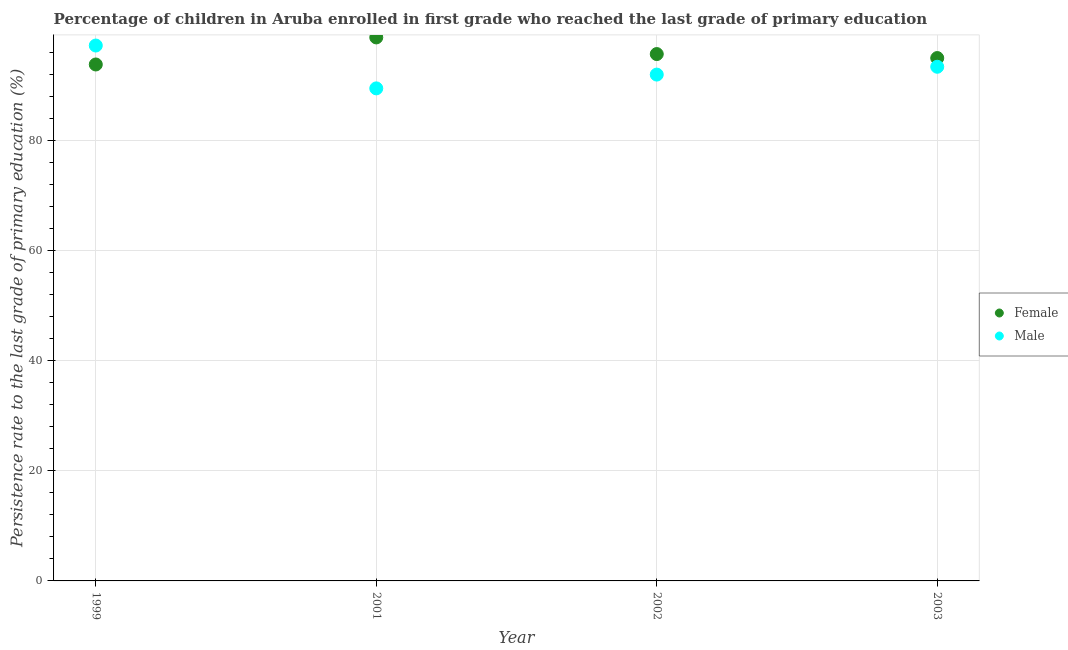How many different coloured dotlines are there?
Give a very brief answer. 2. What is the persistence rate of female students in 2001?
Ensure brevity in your answer.  98.8. Across all years, what is the maximum persistence rate of female students?
Your response must be concise. 98.8. Across all years, what is the minimum persistence rate of female students?
Make the answer very short. 93.88. In which year was the persistence rate of female students minimum?
Give a very brief answer. 1999. What is the total persistence rate of female students in the graph?
Your response must be concise. 383.49. What is the difference between the persistence rate of male students in 2002 and that in 2003?
Offer a terse response. -1.42. What is the difference between the persistence rate of female students in 2003 and the persistence rate of male students in 2002?
Offer a very short reply. 3.01. What is the average persistence rate of male students per year?
Your answer should be very brief. 93.09. In the year 1999, what is the difference between the persistence rate of male students and persistence rate of female students?
Your answer should be very brief. 3.44. What is the ratio of the persistence rate of male students in 2001 to that in 2003?
Ensure brevity in your answer.  0.96. Is the persistence rate of female students in 1999 less than that in 2001?
Offer a terse response. Yes. What is the difference between the highest and the second highest persistence rate of female students?
Make the answer very short. 3.02. What is the difference between the highest and the lowest persistence rate of male students?
Your answer should be very brief. 7.79. Is the sum of the persistence rate of female students in 1999 and 2002 greater than the maximum persistence rate of male students across all years?
Your response must be concise. Yes. Does the persistence rate of male students monotonically increase over the years?
Your answer should be very brief. No. How many years are there in the graph?
Give a very brief answer. 4. What is the difference between two consecutive major ticks on the Y-axis?
Offer a terse response. 20. Are the values on the major ticks of Y-axis written in scientific E-notation?
Provide a succinct answer. No. Does the graph contain any zero values?
Provide a short and direct response. No. Does the graph contain grids?
Provide a succinct answer. Yes. Where does the legend appear in the graph?
Keep it short and to the point. Center right. How many legend labels are there?
Keep it short and to the point. 2. How are the legend labels stacked?
Provide a short and direct response. Vertical. What is the title of the graph?
Your answer should be very brief. Percentage of children in Aruba enrolled in first grade who reached the last grade of primary education. Does "Food and tobacco" appear as one of the legend labels in the graph?
Make the answer very short. No. What is the label or title of the X-axis?
Offer a terse response. Year. What is the label or title of the Y-axis?
Give a very brief answer. Persistence rate to the last grade of primary education (%). What is the Persistence rate to the last grade of primary education (%) in Female in 1999?
Your response must be concise. 93.88. What is the Persistence rate to the last grade of primary education (%) of Male in 1999?
Provide a short and direct response. 97.32. What is the Persistence rate to the last grade of primary education (%) in Female in 2001?
Provide a short and direct response. 98.8. What is the Persistence rate to the last grade of primary education (%) of Male in 2001?
Provide a succinct answer. 89.53. What is the Persistence rate to the last grade of primary education (%) in Female in 2002?
Ensure brevity in your answer.  95.77. What is the Persistence rate to the last grade of primary education (%) in Male in 2002?
Offer a terse response. 92.04. What is the Persistence rate to the last grade of primary education (%) of Female in 2003?
Provide a short and direct response. 95.05. What is the Persistence rate to the last grade of primary education (%) of Male in 2003?
Ensure brevity in your answer.  93.46. Across all years, what is the maximum Persistence rate to the last grade of primary education (%) of Female?
Your answer should be very brief. 98.8. Across all years, what is the maximum Persistence rate to the last grade of primary education (%) of Male?
Your answer should be compact. 97.32. Across all years, what is the minimum Persistence rate to the last grade of primary education (%) of Female?
Offer a very short reply. 93.88. Across all years, what is the minimum Persistence rate to the last grade of primary education (%) in Male?
Provide a succinct answer. 89.53. What is the total Persistence rate to the last grade of primary education (%) of Female in the graph?
Ensure brevity in your answer.  383.49. What is the total Persistence rate to the last grade of primary education (%) in Male in the graph?
Your answer should be compact. 372.36. What is the difference between the Persistence rate to the last grade of primary education (%) of Female in 1999 and that in 2001?
Provide a short and direct response. -4.92. What is the difference between the Persistence rate to the last grade of primary education (%) of Male in 1999 and that in 2001?
Offer a very short reply. 7.79. What is the difference between the Persistence rate to the last grade of primary education (%) in Female in 1999 and that in 2002?
Your response must be concise. -1.89. What is the difference between the Persistence rate to the last grade of primary education (%) in Male in 1999 and that in 2002?
Keep it short and to the point. 5.28. What is the difference between the Persistence rate to the last grade of primary education (%) in Female in 1999 and that in 2003?
Keep it short and to the point. -1.17. What is the difference between the Persistence rate to the last grade of primary education (%) of Male in 1999 and that in 2003?
Ensure brevity in your answer.  3.86. What is the difference between the Persistence rate to the last grade of primary education (%) in Female in 2001 and that in 2002?
Keep it short and to the point. 3.02. What is the difference between the Persistence rate to the last grade of primary education (%) of Male in 2001 and that in 2002?
Give a very brief answer. -2.51. What is the difference between the Persistence rate to the last grade of primary education (%) of Female in 2001 and that in 2003?
Keep it short and to the point. 3.75. What is the difference between the Persistence rate to the last grade of primary education (%) in Male in 2001 and that in 2003?
Ensure brevity in your answer.  -3.93. What is the difference between the Persistence rate to the last grade of primary education (%) of Female in 2002 and that in 2003?
Provide a short and direct response. 0.73. What is the difference between the Persistence rate to the last grade of primary education (%) in Male in 2002 and that in 2003?
Offer a very short reply. -1.42. What is the difference between the Persistence rate to the last grade of primary education (%) in Female in 1999 and the Persistence rate to the last grade of primary education (%) in Male in 2001?
Ensure brevity in your answer.  4.34. What is the difference between the Persistence rate to the last grade of primary education (%) in Female in 1999 and the Persistence rate to the last grade of primary education (%) in Male in 2002?
Offer a terse response. 1.84. What is the difference between the Persistence rate to the last grade of primary education (%) of Female in 1999 and the Persistence rate to the last grade of primary education (%) of Male in 2003?
Offer a terse response. 0.41. What is the difference between the Persistence rate to the last grade of primary education (%) in Female in 2001 and the Persistence rate to the last grade of primary education (%) in Male in 2002?
Ensure brevity in your answer.  6.76. What is the difference between the Persistence rate to the last grade of primary education (%) in Female in 2001 and the Persistence rate to the last grade of primary education (%) in Male in 2003?
Give a very brief answer. 5.33. What is the difference between the Persistence rate to the last grade of primary education (%) of Female in 2002 and the Persistence rate to the last grade of primary education (%) of Male in 2003?
Your response must be concise. 2.31. What is the average Persistence rate to the last grade of primary education (%) of Female per year?
Offer a terse response. 95.87. What is the average Persistence rate to the last grade of primary education (%) of Male per year?
Keep it short and to the point. 93.09. In the year 1999, what is the difference between the Persistence rate to the last grade of primary education (%) in Female and Persistence rate to the last grade of primary education (%) in Male?
Provide a succinct answer. -3.44. In the year 2001, what is the difference between the Persistence rate to the last grade of primary education (%) of Female and Persistence rate to the last grade of primary education (%) of Male?
Offer a very short reply. 9.26. In the year 2002, what is the difference between the Persistence rate to the last grade of primary education (%) in Female and Persistence rate to the last grade of primary education (%) in Male?
Provide a short and direct response. 3.73. In the year 2003, what is the difference between the Persistence rate to the last grade of primary education (%) of Female and Persistence rate to the last grade of primary education (%) of Male?
Ensure brevity in your answer.  1.58. What is the ratio of the Persistence rate to the last grade of primary education (%) in Female in 1999 to that in 2001?
Your response must be concise. 0.95. What is the ratio of the Persistence rate to the last grade of primary education (%) in Male in 1999 to that in 2001?
Your answer should be compact. 1.09. What is the ratio of the Persistence rate to the last grade of primary education (%) in Female in 1999 to that in 2002?
Ensure brevity in your answer.  0.98. What is the ratio of the Persistence rate to the last grade of primary education (%) in Male in 1999 to that in 2002?
Your response must be concise. 1.06. What is the ratio of the Persistence rate to the last grade of primary education (%) in Male in 1999 to that in 2003?
Keep it short and to the point. 1.04. What is the ratio of the Persistence rate to the last grade of primary education (%) of Female in 2001 to that in 2002?
Keep it short and to the point. 1.03. What is the ratio of the Persistence rate to the last grade of primary education (%) of Male in 2001 to that in 2002?
Your response must be concise. 0.97. What is the ratio of the Persistence rate to the last grade of primary education (%) in Female in 2001 to that in 2003?
Your response must be concise. 1.04. What is the ratio of the Persistence rate to the last grade of primary education (%) of Male in 2001 to that in 2003?
Ensure brevity in your answer.  0.96. What is the ratio of the Persistence rate to the last grade of primary education (%) in Female in 2002 to that in 2003?
Provide a succinct answer. 1.01. What is the difference between the highest and the second highest Persistence rate to the last grade of primary education (%) in Female?
Your answer should be compact. 3.02. What is the difference between the highest and the second highest Persistence rate to the last grade of primary education (%) of Male?
Ensure brevity in your answer.  3.86. What is the difference between the highest and the lowest Persistence rate to the last grade of primary education (%) of Female?
Make the answer very short. 4.92. What is the difference between the highest and the lowest Persistence rate to the last grade of primary education (%) in Male?
Provide a succinct answer. 7.79. 